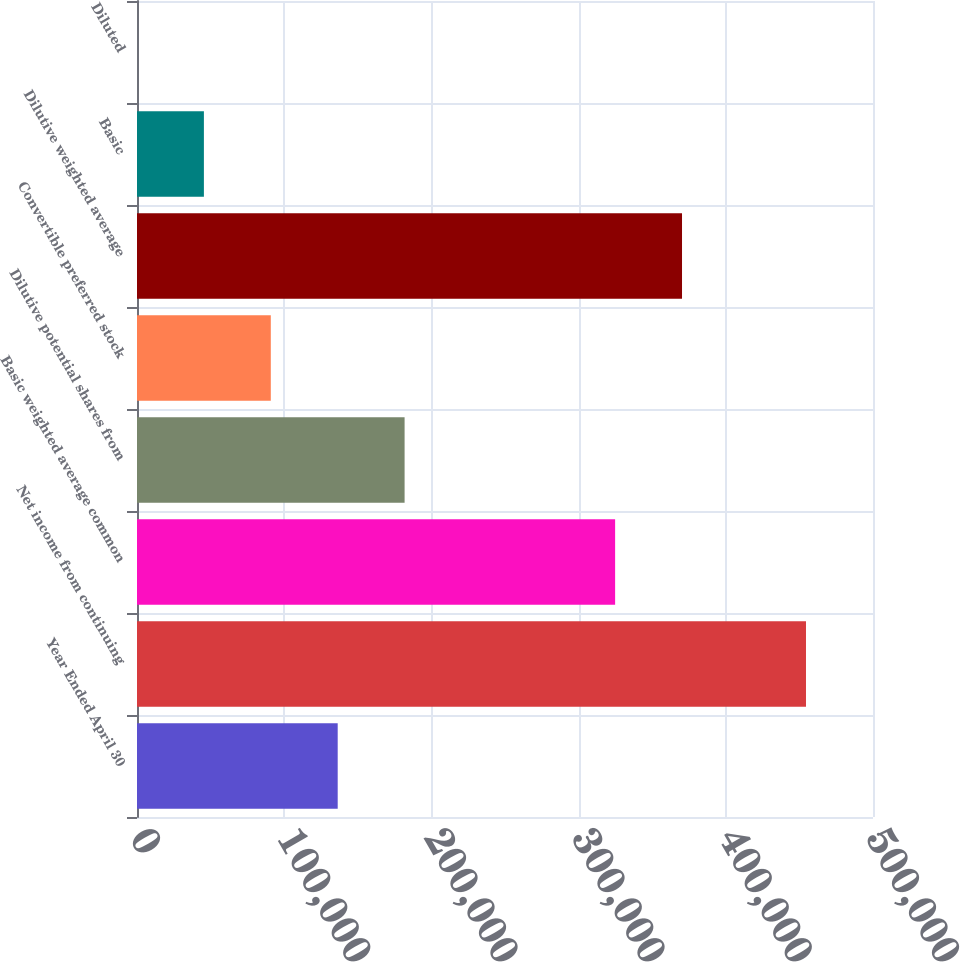Convert chart to OTSL. <chart><loc_0><loc_0><loc_500><loc_500><bar_chart><fcel>Year Ended April 30<fcel>Net income from continuing<fcel>Basic weighted average common<fcel>Dilutive potential shares from<fcel>Convertible preferred stock<fcel>Dilutive weighted average<fcel>Basic<fcel>Diluted<nl><fcel>136344<fcel>454476<fcel>324810<fcel>181791<fcel>90896.3<fcel>370257<fcel>45448.8<fcel>1.39<nl></chart> 